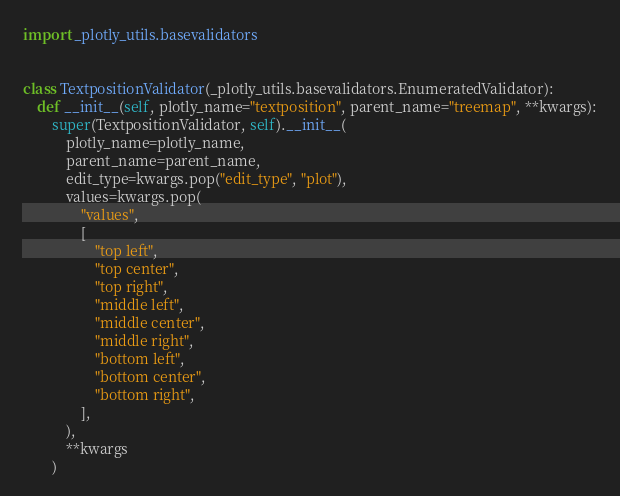<code> <loc_0><loc_0><loc_500><loc_500><_Python_>import _plotly_utils.basevalidators


class TextpositionValidator(_plotly_utils.basevalidators.EnumeratedValidator):
    def __init__(self, plotly_name="textposition", parent_name="treemap", **kwargs):
        super(TextpositionValidator, self).__init__(
            plotly_name=plotly_name,
            parent_name=parent_name,
            edit_type=kwargs.pop("edit_type", "plot"),
            values=kwargs.pop(
                "values",
                [
                    "top left",
                    "top center",
                    "top right",
                    "middle left",
                    "middle center",
                    "middle right",
                    "bottom left",
                    "bottom center",
                    "bottom right",
                ],
            ),
            **kwargs
        )
</code> 